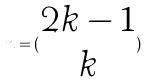<formula> <loc_0><loc_0><loc_500><loc_500>n = ( \begin{matrix} 2 k - 1 \\ k \end{matrix} )</formula> 